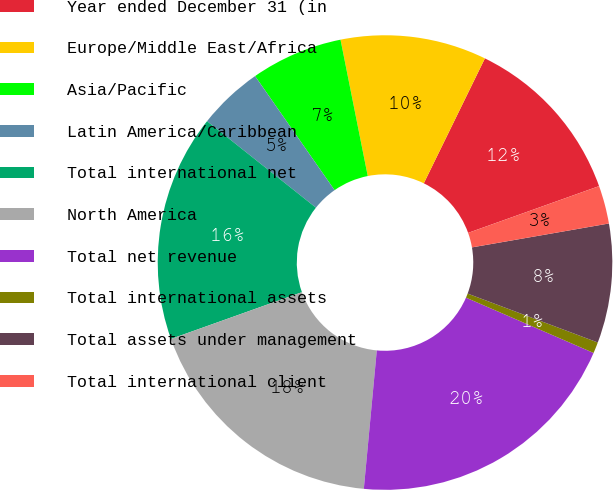Convert chart. <chart><loc_0><loc_0><loc_500><loc_500><pie_chart><fcel>Year ended December 31 (in<fcel>Europe/Middle East/Africa<fcel>Asia/Pacific<fcel>Latin America/Caribbean<fcel>Total international net<fcel>North America<fcel>Total net revenue<fcel>Total international assets<fcel>Total assets under management<fcel>Total international client<nl><fcel>12.3%<fcel>10.38%<fcel>6.55%<fcel>4.63%<fcel>16.14%<fcel>18.06%<fcel>19.98%<fcel>0.79%<fcel>8.47%<fcel>2.71%<nl></chart> 